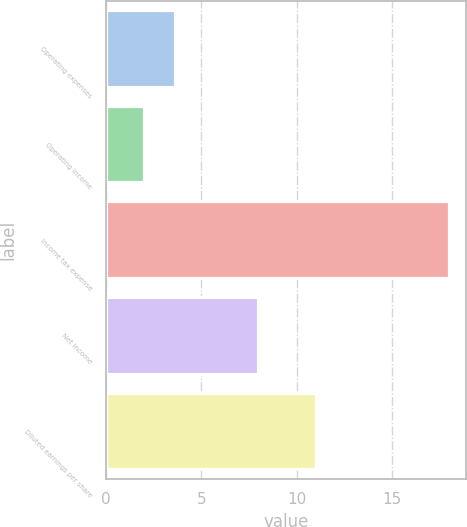<chart> <loc_0><loc_0><loc_500><loc_500><bar_chart><fcel>Operating expenses<fcel>Operating income<fcel>Income tax expense<fcel>Net income<fcel>Diluted earnings per share<nl><fcel>3.6<fcel>2<fcel>18<fcel>8<fcel>11<nl></chart> 